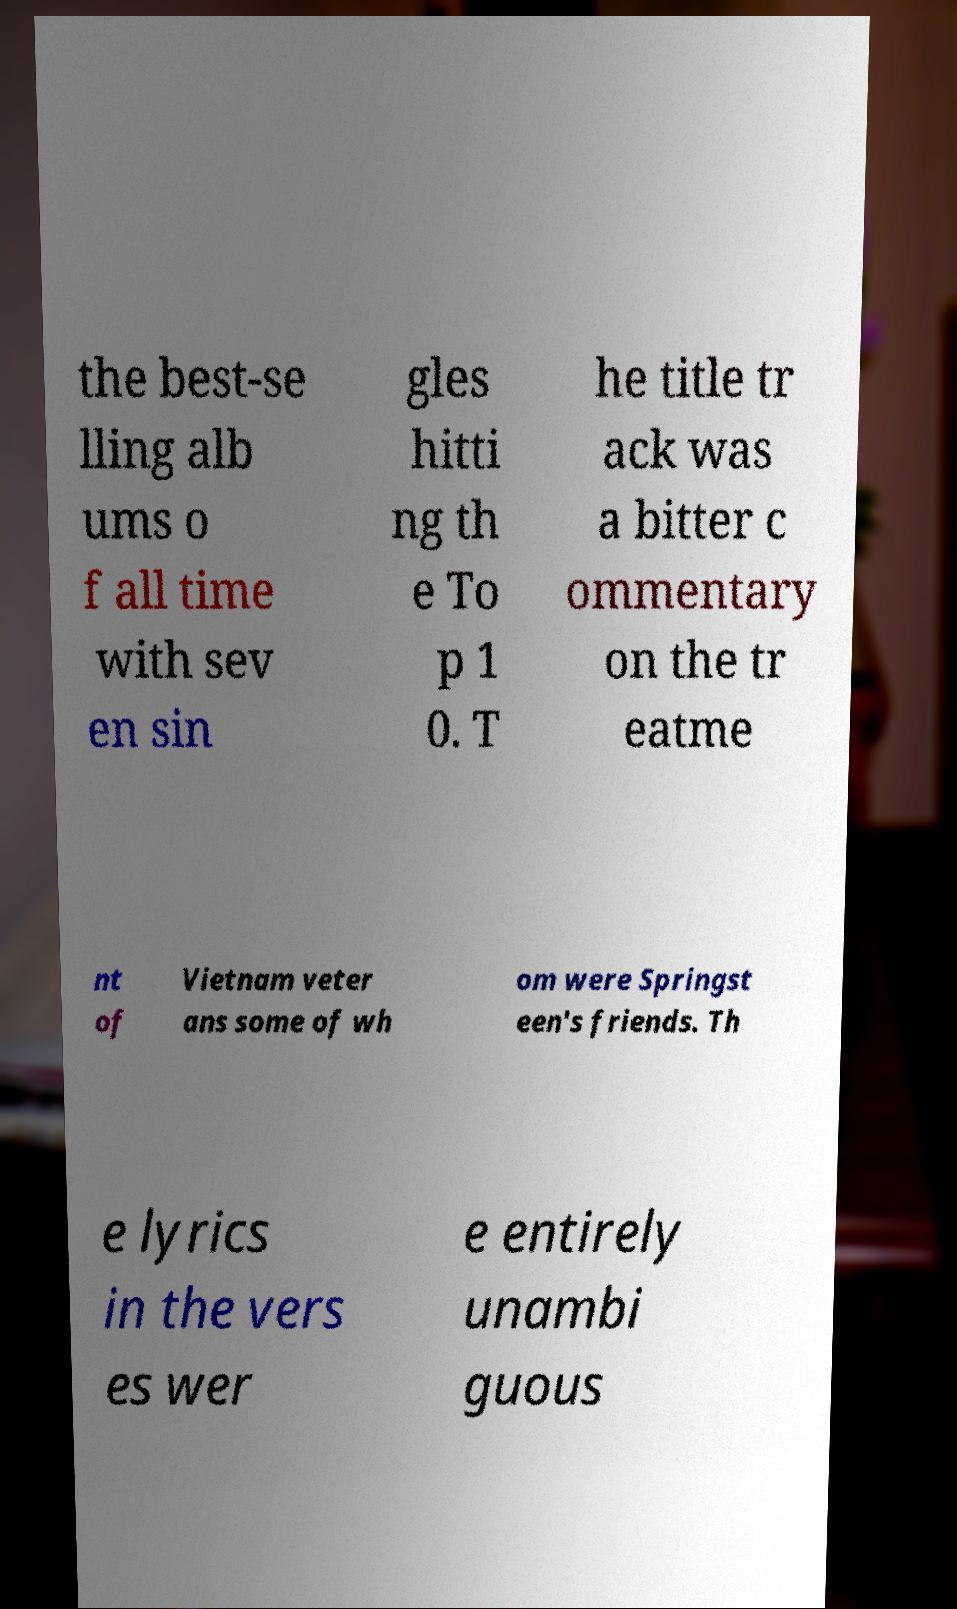I need the written content from this picture converted into text. Can you do that? the best-se lling alb ums o f all time with sev en sin gles hitti ng th e To p 1 0. T he title tr ack was a bitter c ommentary on the tr eatme nt of Vietnam veter ans some of wh om were Springst een's friends. Th e lyrics in the vers es wer e entirely unambi guous 